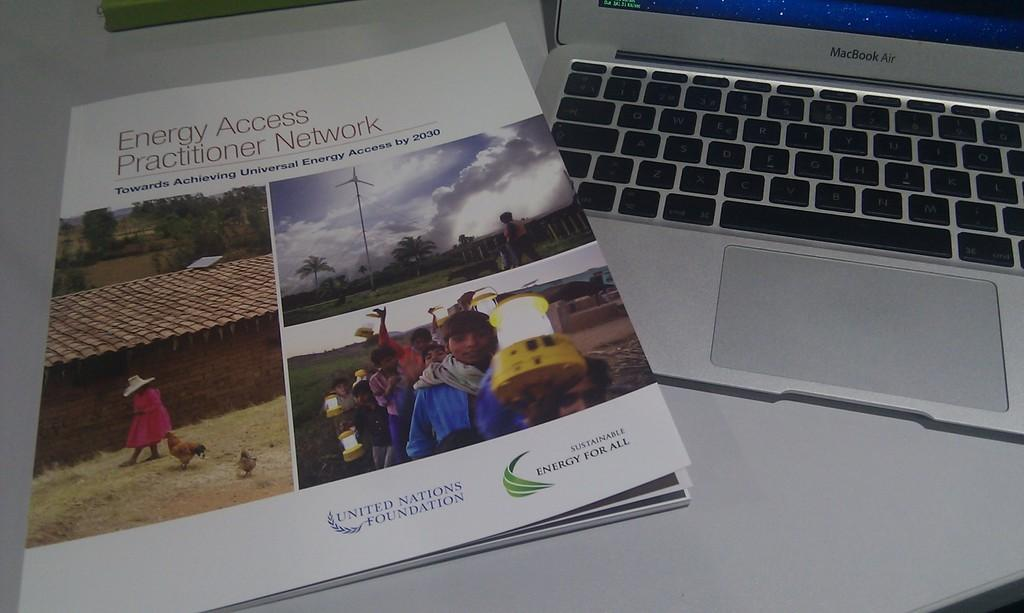<image>
Create a compact narrative representing the image presented. An copy of the Energy Access Practitioner Network is placed on top of a lap top. 